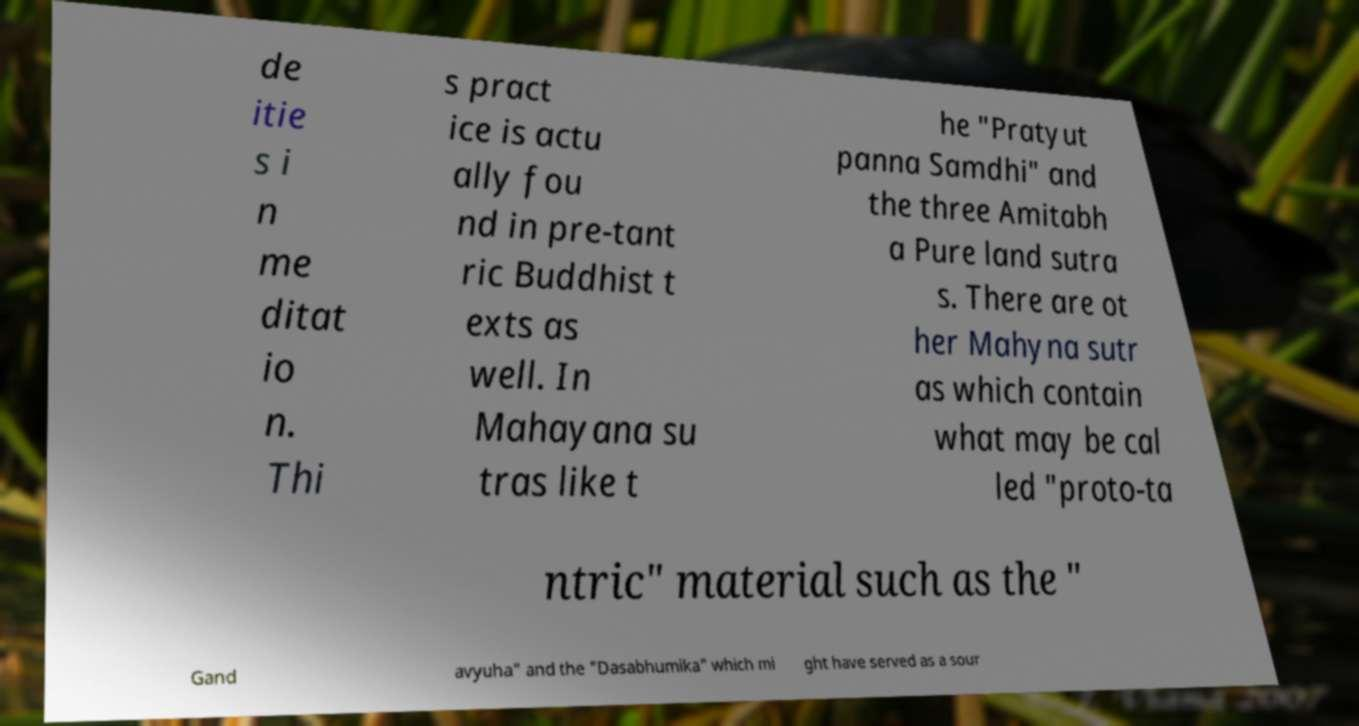What messages or text are displayed in this image? I need them in a readable, typed format. de itie s i n me ditat io n. Thi s pract ice is actu ally fou nd in pre-tant ric Buddhist t exts as well. In Mahayana su tras like t he "Pratyut panna Samdhi" and the three Amitabh a Pure land sutra s. There are ot her Mahyna sutr as which contain what may be cal led "proto-ta ntric" material such as the " Gand avyuha" and the "Dasabhumika" which mi ght have served as a sour 